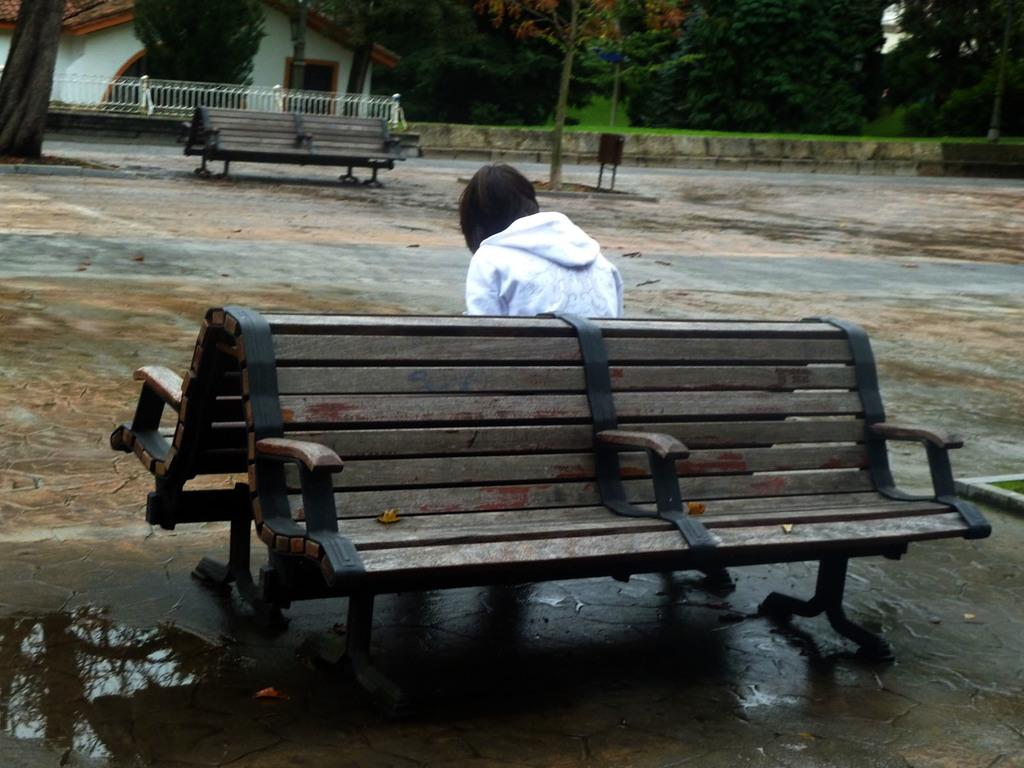What type of seating is available in the image? There are benches in the image. Is anyone using the benches? Yes, a person is sitting on one of the benches. What is on the ground in the image? There is water on the ground. Can you describe the background of the image? In the background, there are additional benches, trees, a railing, and a building. What type of tax is being discussed in the image? There is no mention of tax in the image; it features benches, a person sitting on one, water on the ground, and various elements in the background. 